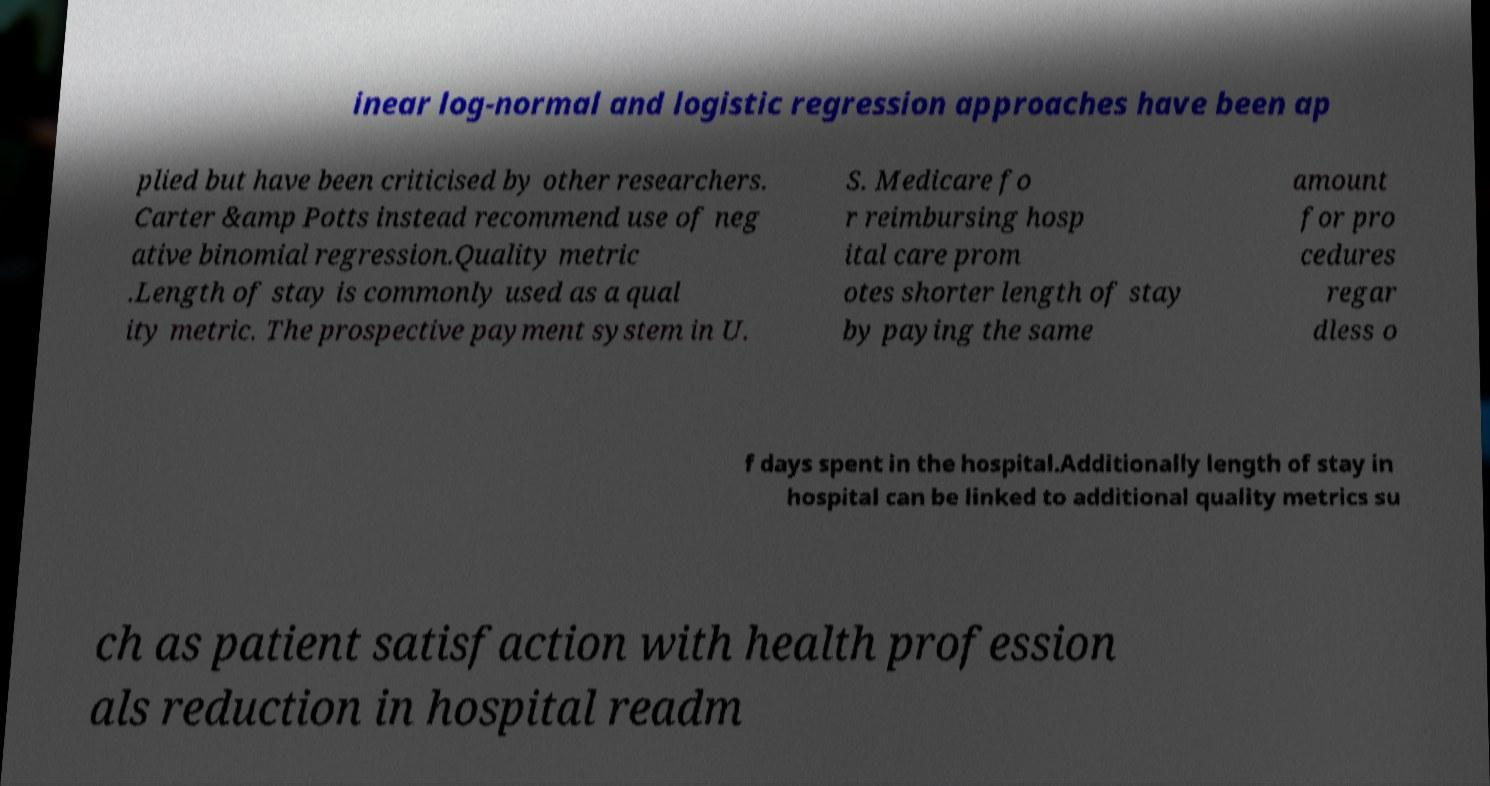For documentation purposes, I need the text within this image transcribed. Could you provide that? inear log-normal and logistic regression approaches have been ap plied but have been criticised by other researchers. Carter &amp Potts instead recommend use of neg ative binomial regression.Quality metric .Length of stay is commonly used as a qual ity metric. The prospective payment system in U. S. Medicare fo r reimbursing hosp ital care prom otes shorter length of stay by paying the same amount for pro cedures regar dless o f days spent in the hospital.Additionally length of stay in hospital can be linked to additional quality metrics su ch as patient satisfaction with health profession als reduction in hospital readm 